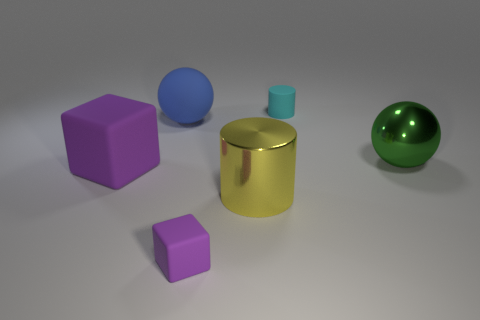Subtract all cylinders. How many objects are left? 4 Add 2 rubber balls. How many objects exist? 8 Add 4 green balls. How many green balls are left? 5 Add 3 tiny brown metallic balls. How many tiny brown metallic balls exist? 3 Subtract 0 brown balls. How many objects are left? 6 Subtract all purple cubes. Subtract all cyan rubber cylinders. How many objects are left? 3 